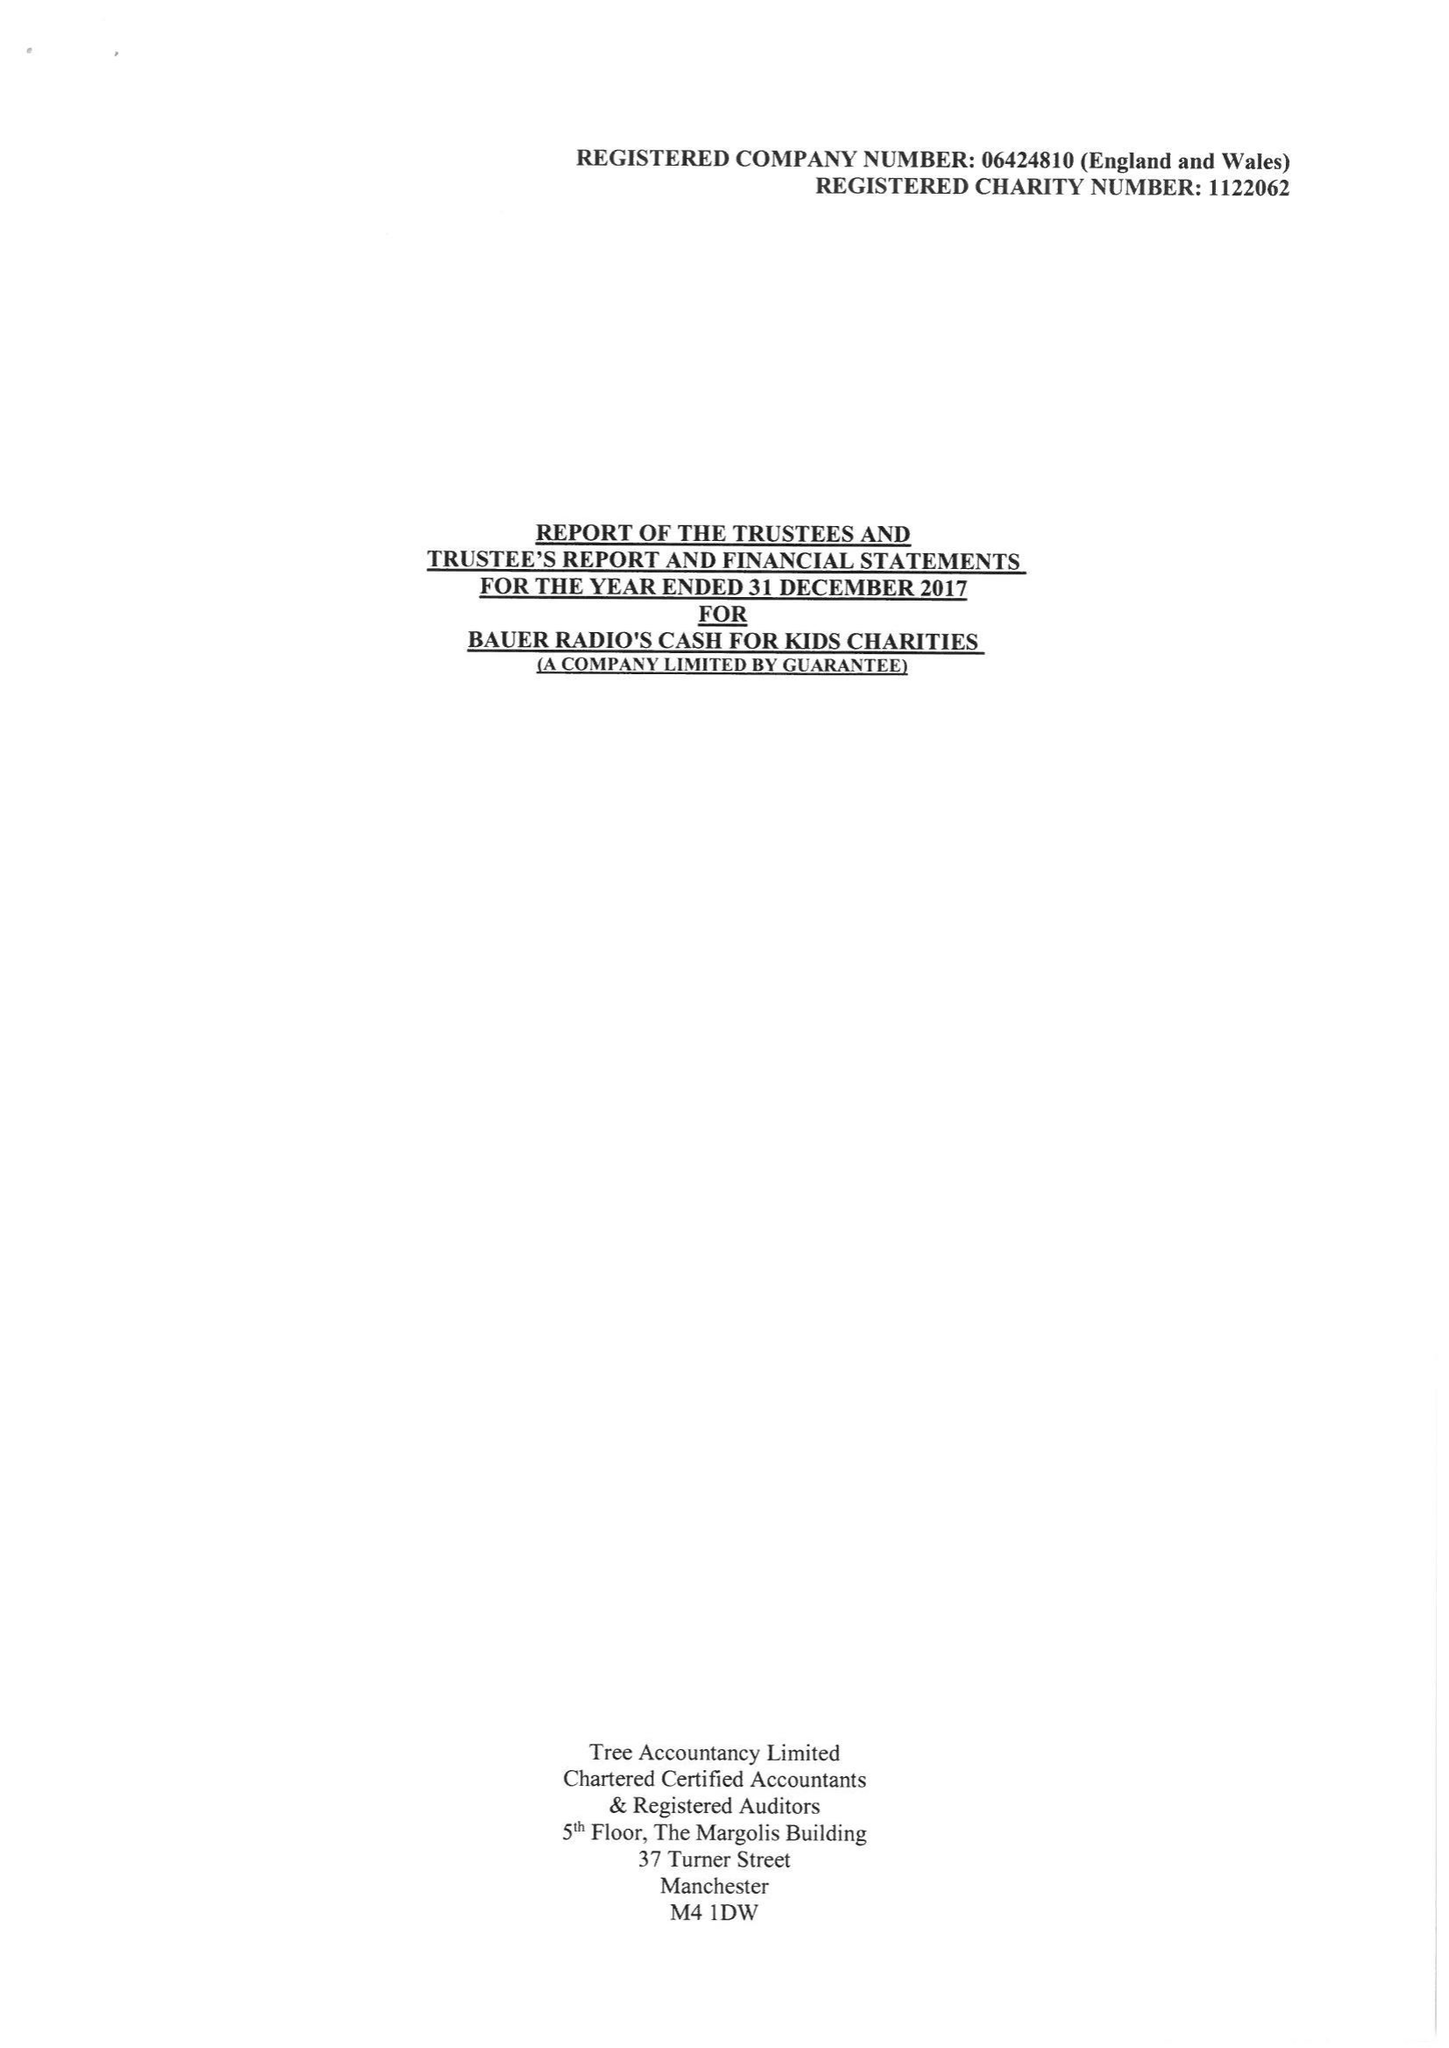What is the value for the report_date?
Answer the question using a single word or phrase. 2017-12-31 